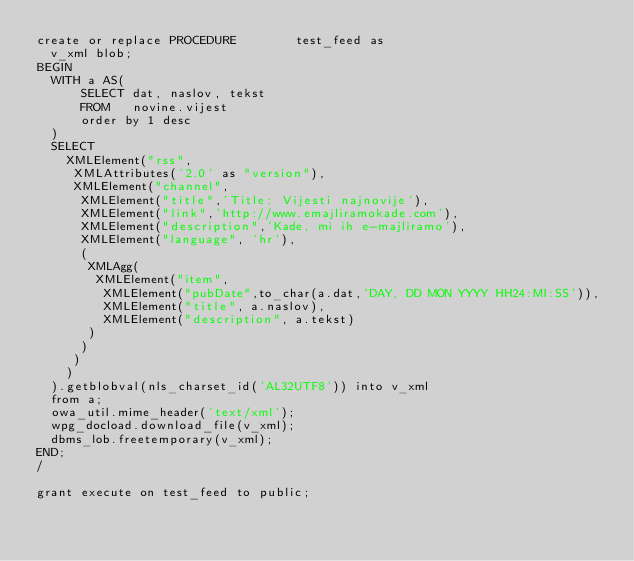Convert code to text. <code><loc_0><loc_0><loc_500><loc_500><_SQL_>create or replace PROCEDURE        test_feed as
  v_xml blob;
BEGIN
  WITH a AS(
      SELECT dat, naslov, tekst
      FROM   novine.vijest
      order by 1 desc
  )
  SELECT
    XMLElement("rss",
     XMLAttributes('2.0' as "version"),
     XMLElement("channel",
      XMLElement("title",'Title: Vijesti najnovije'),
      XMLElement("link",'http://www.emajliramokade.com'),
      XMLElement("description",'Kade, mi ih e-majliramo'),
      XMLElement("language", 'hr'),
      (
       XMLAgg(
        XMLElement("item",
         XMLElement("pubDate",to_char(a.dat,'DAY, DD MON YYYY HH24:MI:SS')),
         XMLElement("title", a.naslov),
         XMLElement("description", a.tekst)
       )
      )
     )
    )
  ).getblobval(nls_charset_id('AL32UTF8')) into v_xml
  from a;
  owa_util.mime_header('text/xml');
  wpg_docload.download_file(v_xml);
  dbms_lob.freetemporary(v_xml);
END;
/

grant execute on test_feed to public;</code> 